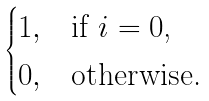<formula> <loc_0><loc_0><loc_500><loc_500>\begin{cases} 1 , & \text {if $i=0$,} \\ 0 , & \text {otherwise.} \end{cases}</formula> 